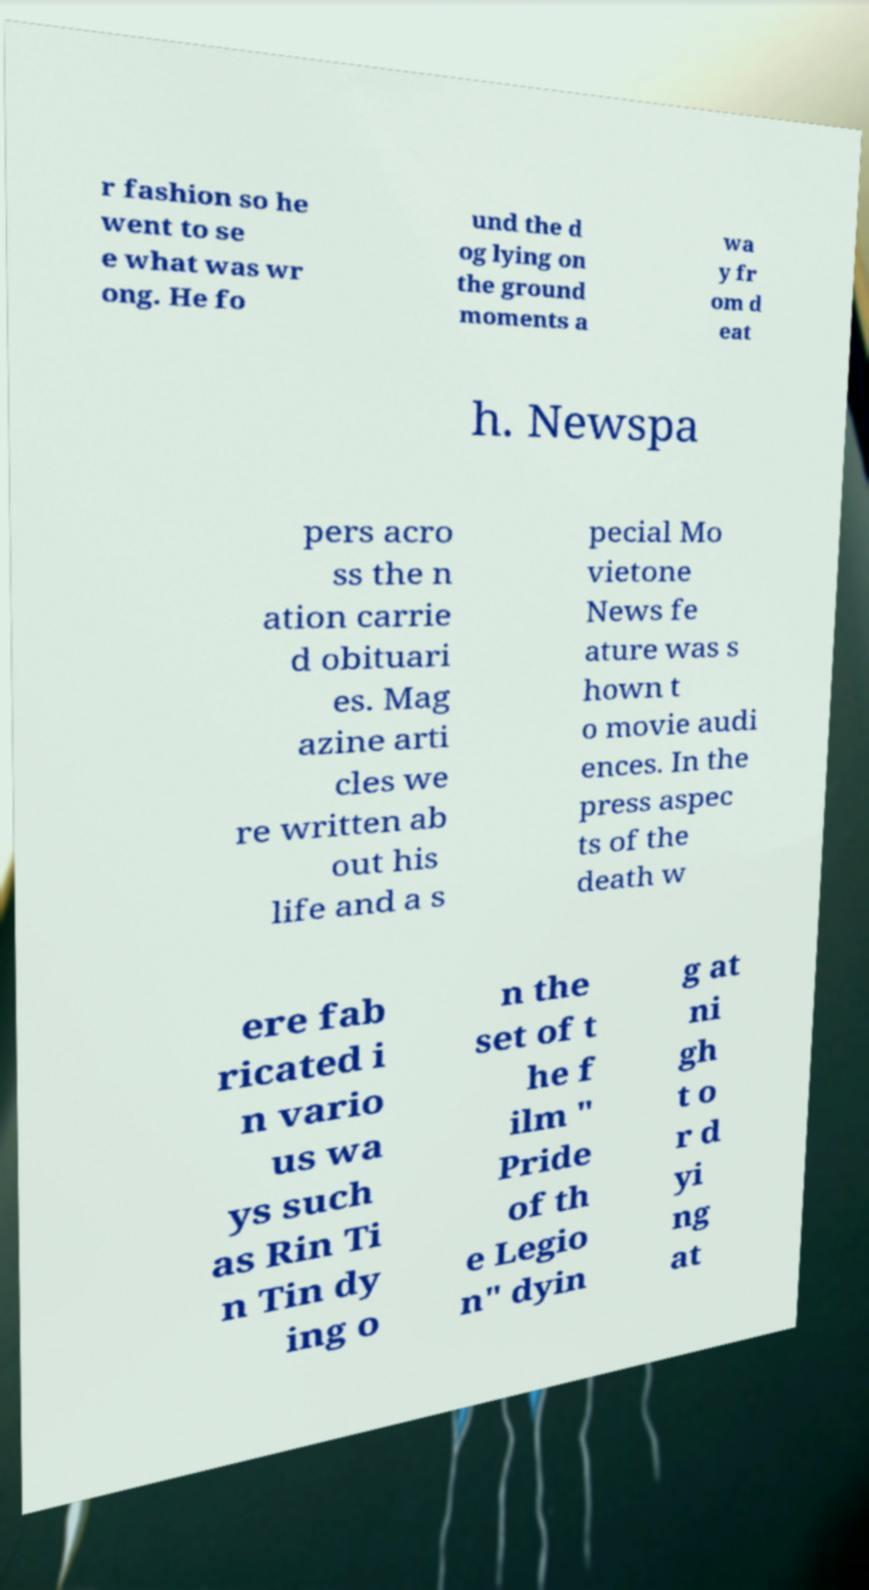Can you read and provide the text displayed in the image?This photo seems to have some interesting text. Can you extract and type it out for me? r fashion so he went to se e what was wr ong. He fo und the d og lying on the ground moments a wa y fr om d eat h. Newspa pers acro ss the n ation carrie d obituari es. Mag azine arti cles we re written ab out his life and a s pecial Mo vietone News fe ature was s hown t o movie audi ences. In the press aspec ts of the death w ere fab ricated i n vario us wa ys such as Rin Ti n Tin dy ing o n the set of t he f ilm " Pride of th e Legio n" dyin g at ni gh t o r d yi ng at 